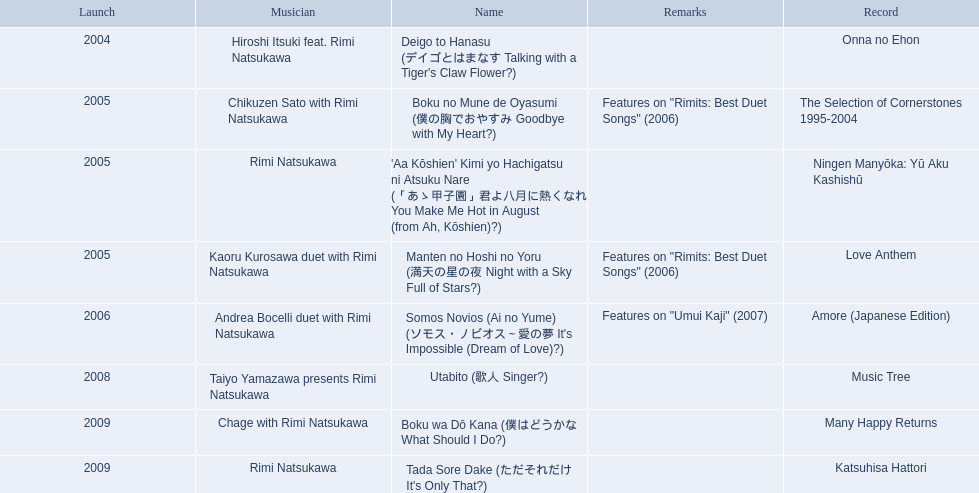What are all of the titles? Deigo to Hanasu (デイゴとはまなす Talking with a Tiger's Claw Flower?), Boku no Mune de Oyasumi (僕の胸でおやすみ Goodbye with My Heart?), 'Aa Kōshien' Kimi yo Hachigatsu ni Atsuku Nare (「あゝ甲子園」君よ八月に熱くなれ You Make Me Hot in August (from Ah, Kōshien)?), Manten no Hoshi no Yoru (満天の星の夜 Night with a Sky Full of Stars?), Somos Novios (Ai no Yume) (ソモス・ノビオス～愛の夢 It's Impossible (Dream of Love)?), Utabito (歌人 Singer?), Boku wa Dō Kana (僕はどうかな What Should I Do?), Tada Sore Dake (ただそれだけ It's Only That?). What are their notes? , Features on "Rimits: Best Duet Songs" (2006), , Features on "Rimits: Best Duet Songs" (2006), Features on "Umui Kaji" (2007), , , . Which title shares its notes with manten no hoshi no yoru (man tian noxing noye night with a sky full of stars?)? Boku no Mune de Oyasumi (僕の胸でおやすみ Goodbye with My Heart?). 